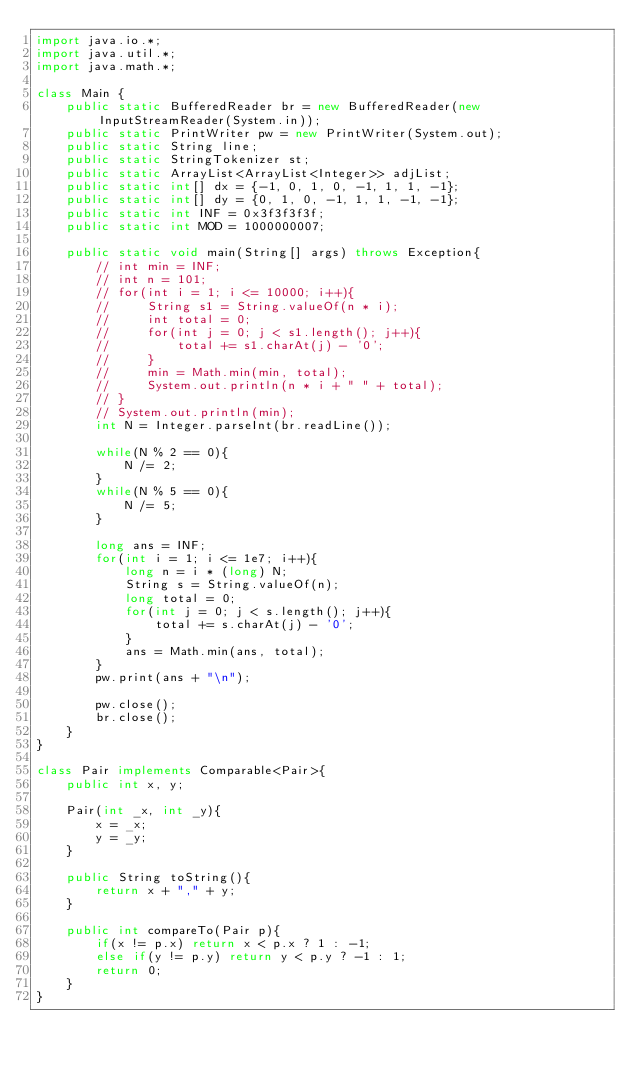<code> <loc_0><loc_0><loc_500><loc_500><_Java_>import java.io.*;
import java.util.*;
import java.math.*;

class Main {
    public static BufferedReader br = new BufferedReader(new InputStreamReader(System.in));
    public static PrintWriter pw = new PrintWriter(System.out);
    public static String line;
    public static StringTokenizer st;
    public static ArrayList<ArrayList<Integer>> adjList;
    public static int[] dx = {-1, 0, 1, 0, -1, 1, 1, -1};
    public static int[] dy = {0, 1, 0, -1, 1, 1, -1, -1};
    public static int INF = 0x3f3f3f3f;
    public static int MOD = 1000000007;

    public static void main(String[] args) throws Exception{
        // int min = INF;
        // int n = 101;
        // for(int i = 1; i <= 10000; i++){
        //     String s1 = String.valueOf(n * i);
        //     int total = 0;
        //     for(int j = 0; j < s1.length(); j++){
        //         total += s1.charAt(j) - '0';
        //     }
        //     min = Math.min(min, total);
        //     System.out.println(n * i + " " + total);
        // }
        // System.out.println(min);
        int N = Integer.parseInt(br.readLine());

        while(N % 2 == 0){
            N /= 2;
        }
        while(N % 5 == 0){
            N /= 5;
        }

        long ans = INF;
        for(int i = 1; i <= 1e7; i++){
            long n = i * (long) N;
            String s = String.valueOf(n);
            long total = 0;
            for(int j = 0; j < s.length(); j++){
                total += s.charAt(j) - '0';
            }
            ans = Math.min(ans, total);
        }
        pw.print(ans + "\n");

        pw.close(); 
        br.close();
    }
}

class Pair implements Comparable<Pair>{
    public int x, y;

    Pair(int _x, int _y){
        x = _x;
        y = _y;
    }

    public String toString(){
        return x + "," + y;
    }

    public int compareTo(Pair p){
        if(x != p.x) return x < p.x ? 1 : -1;
        else if(y != p.y) return y < p.y ? -1 : 1;
        return 0;
    }
}</code> 